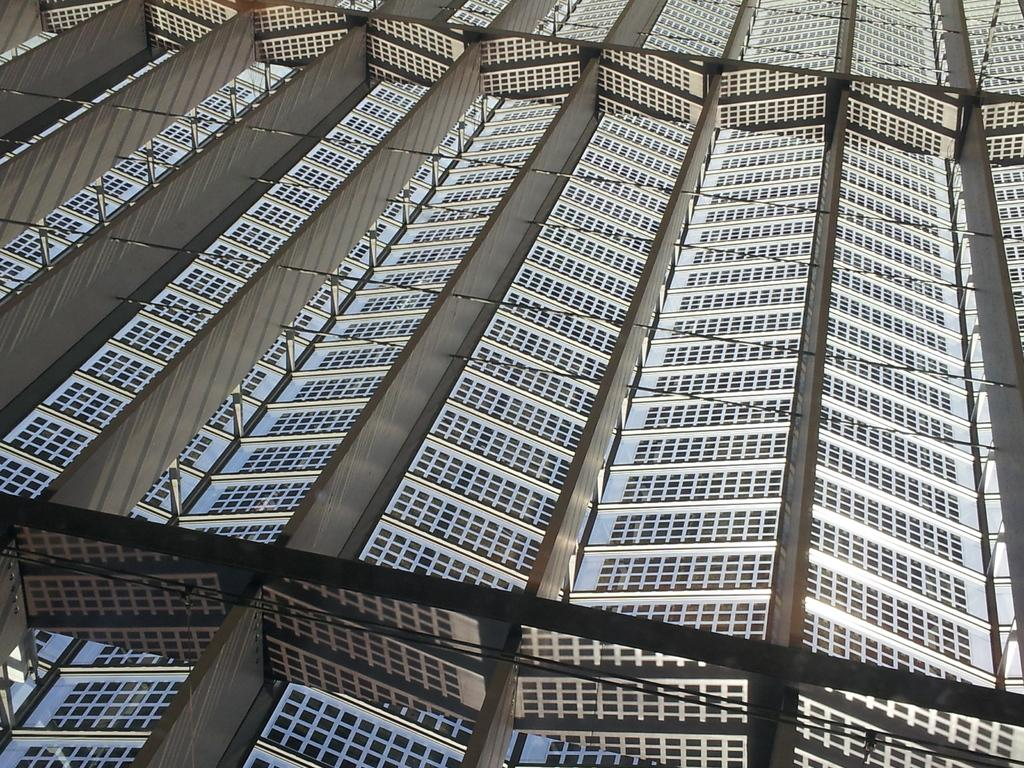What type of energy-generating equipment is visible in the image? There are solar panels in the image. What is the primary purpose of the solar panels? The solar panels are designed to generate electricity from sunlight. Can you describe the appearance of the solar panels? The solar panels are typically made of photovoltaic cells and have a flat, rectangular shape. What type of flower is growing near the solar panels in the image? There are no flowers visible in the image; it only features solar panels. 